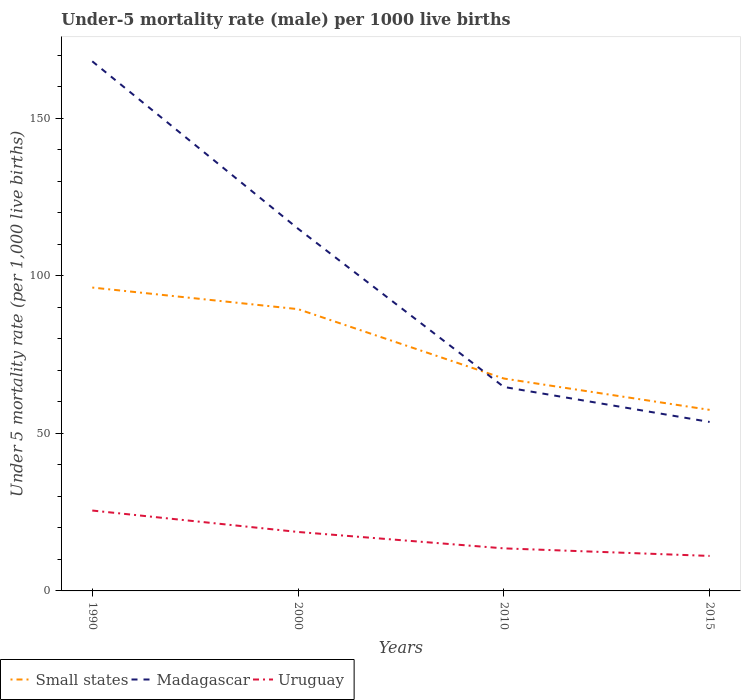How many different coloured lines are there?
Your response must be concise. 3. Does the line corresponding to Uruguay intersect with the line corresponding to Madagascar?
Your answer should be compact. No. Across all years, what is the maximum under-five mortality rate in Small states?
Provide a succinct answer. 57.43. In which year was the under-five mortality rate in Madagascar maximum?
Give a very brief answer. 2015. What is the total under-five mortality rate in Uruguay in the graph?
Keep it short and to the point. 6.8. What is the difference between the highest and the second highest under-five mortality rate in Small states?
Make the answer very short. 38.8. What is the difference between the highest and the lowest under-five mortality rate in Small states?
Make the answer very short. 2. Are the values on the major ticks of Y-axis written in scientific E-notation?
Your response must be concise. No. Does the graph contain grids?
Your answer should be compact. No. Where does the legend appear in the graph?
Your answer should be very brief. Bottom left. What is the title of the graph?
Your answer should be compact. Under-5 mortality rate (male) per 1000 live births. Does "Kuwait" appear as one of the legend labels in the graph?
Make the answer very short. No. What is the label or title of the Y-axis?
Give a very brief answer. Under 5 mortality rate (per 1,0 live births). What is the Under 5 mortality rate (per 1,000 live births) in Small states in 1990?
Your response must be concise. 96.23. What is the Under 5 mortality rate (per 1,000 live births) in Madagascar in 1990?
Your answer should be compact. 168. What is the Under 5 mortality rate (per 1,000 live births) of Uruguay in 1990?
Ensure brevity in your answer.  25.5. What is the Under 5 mortality rate (per 1,000 live births) in Small states in 2000?
Your answer should be very brief. 89.38. What is the Under 5 mortality rate (per 1,000 live births) of Madagascar in 2000?
Keep it short and to the point. 114.9. What is the Under 5 mortality rate (per 1,000 live births) of Uruguay in 2000?
Your answer should be very brief. 18.7. What is the Under 5 mortality rate (per 1,000 live births) of Small states in 2010?
Give a very brief answer. 67.37. What is the Under 5 mortality rate (per 1,000 live births) of Madagascar in 2010?
Your response must be concise. 64.7. What is the Under 5 mortality rate (per 1,000 live births) of Small states in 2015?
Give a very brief answer. 57.43. What is the Under 5 mortality rate (per 1,000 live births) of Madagascar in 2015?
Offer a very short reply. 53.6. Across all years, what is the maximum Under 5 mortality rate (per 1,000 live births) in Small states?
Offer a very short reply. 96.23. Across all years, what is the maximum Under 5 mortality rate (per 1,000 live births) of Madagascar?
Give a very brief answer. 168. Across all years, what is the minimum Under 5 mortality rate (per 1,000 live births) of Small states?
Give a very brief answer. 57.43. Across all years, what is the minimum Under 5 mortality rate (per 1,000 live births) in Madagascar?
Provide a short and direct response. 53.6. Across all years, what is the minimum Under 5 mortality rate (per 1,000 live births) of Uruguay?
Provide a succinct answer. 11.1. What is the total Under 5 mortality rate (per 1,000 live births) of Small states in the graph?
Offer a terse response. 310.42. What is the total Under 5 mortality rate (per 1,000 live births) in Madagascar in the graph?
Your answer should be compact. 401.2. What is the total Under 5 mortality rate (per 1,000 live births) of Uruguay in the graph?
Make the answer very short. 68.8. What is the difference between the Under 5 mortality rate (per 1,000 live births) of Small states in 1990 and that in 2000?
Your response must be concise. 6.85. What is the difference between the Under 5 mortality rate (per 1,000 live births) of Madagascar in 1990 and that in 2000?
Keep it short and to the point. 53.1. What is the difference between the Under 5 mortality rate (per 1,000 live births) in Small states in 1990 and that in 2010?
Provide a succinct answer. 28.86. What is the difference between the Under 5 mortality rate (per 1,000 live births) of Madagascar in 1990 and that in 2010?
Offer a very short reply. 103.3. What is the difference between the Under 5 mortality rate (per 1,000 live births) of Uruguay in 1990 and that in 2010?
Your answer should be very brief. 12. What is the difference between the Under 5 mortality rate (per 1,000 live births) in Small states in 1990 and that in 2015?
Offer a very short reply. 38.8. What is the difference between the Under 5 mortality rate (per 1,000 live births) in Madagascar in 1990 and that in 2015?
Your answer should be compact. 114.4. What is the difference between the Under 5 mortality rate (per 1,000 live births) in Uruguay in 1990 and that in 2015?
Give a very brief answer. 14.4. What is the difference between the Under 5 mortality rate (per 1,000 live births) in Small states in 2000 and that in 2010?
Provide a short and direct response. 22.01. What is the difference between the Under 5 mortality rate (per 1,000 live births) of Madagascar in 2000 and that in 2010?
Make the answer very short. 50.2. What is the difference between the Under 5 mortality rate (per 1,000 live births) in Small states in 2000 and that in 2015?
Offer a terse response. 31.95. What is the difference between the Under 5 mortality rate (per 1,000 live births) of Madagascar in 2000 and that in 2015?
Make the answer very short. 61.3. What is the difference between the Under 5 mortality rate (per 1,000 live births) of Uruguay in 2000 and that in 2015?
Your answer should be compact. 7.6. What is the difference between the Under 5 mortality rate (per 1,000 live births) in Small states in 2010 and that in 2015?
Offer a very short reply. 9.94. What is the difference between the Under 5 mortality rate (per 1,000 live births) of Uruguay in 2010 and that in 2015?
Provide a short and direct response. 2.4. What is the difference between the Under 5 mortality rate (per 1,000 live births) in Small states in 1990 and the Under 5 mortality rate (per 1,000 live births) in Madagascar in 2000?
Ensure brevity in your answer.  -18.67. What is the difference between the Under 5 mortality rate (per 1,000 live births) of Small states in 1990 and the Under 5 mortality rate (per 1,000 live births) of Uruguay in 2000?
Your answer should be compact. 77.53. What is the difference between the Under 5 mortality rate (per 1,000 live births) in Madagascar in 1990 and the Under 5 mortality rate (per 1,000 live births) in Uruguay in 2000?
Your answer should be compact. 149.3. What is the difference between the Under 5 mortality rate (per 1,000 live births) of Small states in 1990 and the Under 5 mortality rate (per 1,000 live births) of Madagascar in 2010?
Offer a terse response. 31.53. What is the difference between the Under 5 mortality rate (per 1,000 live births) in Small states in 1990 and the Under 5 mortality rate (per 1,000 live births) in Uruguay in 2010?
Keep it short and to the point. 82.73. What is the difference between the Under 5 mortality rate (per 1,000 live births) of Madagascar in 1990 and the Under 5 mortality rate (per 1,000 live births) of Uruguay in 2010?
Your answer should be compact. 154.5. What is the difference between the Under 5 mortality rate (per 1,000 live births) in Small states in 1990 and the Under 5 mortality rate (per 1,000 live births) in Madagascar in 2015?
Ensure brevity in your answer.  42.63. What is the difference between the Under 5 mortality rate (per 1,000 live births) in Small states in 1990 and the Under 5 mortality rate (per 1,000 live births) in Uruguay in 2015?
Give a very brief answer. 85.13. What is the difference between the Under 5 mortality rate (per 1,000 live births) of Madagascar in 1990 and the Under 5 mortality rate (per 1,000 live births) of Uruguay in 2015?
Your answer should be compact. 156.9. What is the difference between the Under 5 mortality rate (per 1,000 live births) in Small states in 2000 and the Under 5 mortality rate (per 1,000 live births) in Madagascar in 2010?
Keep it short and to the point. 24.68. What is the difference between the Under 5 mortality rate (per 1,000 live births) in Small states in 2000 and the Under 5 mortality rate (per 1,000 live births) in Uruguay in 2010?
Your answer should be compact. 75.88. What is the difference between the Under 5 mortality rate (per 1,000 live births) in Madagascar in 2000 and the Under 5 mortality rate (per 1,000 live births) in Uruguay in 2010?
Give a very brief answer. 101.4. What is the difference between the Under 5 mortality rate (per 1,000 live births) in Small states in 2000 and the Under 5 mortality rate (per 1,000 live births) in Madagascar in 2015?
Keep it short and to the point. 35.78. What is the difference between the Under 5 mortality rate (per 1,000 live births) of Small states in 2000 and the Under 5 mortality rate (per 1,000 live births) of Uruguay in 2015?
Provide a short and direct response. 78.28. What is the difference between the Under 5 mortality rate (per 1,000 live births) of Madagascar in 2000 and the Under 5 mortality rate (per 1,000 live births) of Uruguay in 2015?
Your response must be concise. 103.8. What is the difference between the Under 5 mortality rate (per 1,000 live births) in Small states in 2010 and the Under 5 mortality rate (per 1,000 live births) in Madagascar in 2015?
Make the answer very short. 13.77. What is the difference between the Under 5 mortality rate (per 1,000 live births) of Small states in 2010 and the Under 5 mortality rate (per 1,000 live births) of Uruguay in 2015?
Provide a succinct answer. 56.27. What is the difference between the Under 5 mortality rate (per 1,000 live births) in Madagascar in 2010 and the Under 5 mortality rate (per 1,000 live births) in Uruguay in 2015?
Provide a succinct answer. 53.6. What is the average Under 5 mortality rate (per 1,000 live births) in Small states per year?
Make the answer very short. 77.6. What is the average Under 5 mortality rate (per 1,000 live births) of Madagascar per year?
Make the answer very short. 100.3. What is the average Under 5 mortality rate (per 1,000 live births) in Uruguay per year?
Your answer should be compact. 17.2. In the year 1990, what is the difference between the Under 5 mortality rate (per 1,000 live births) of Small states and Under 5 mortality rate (per 1,000 live births) of Madagascar?
Your answer should be compact. -71.77. In the year 1990, what is the difference between the Under 5 mortality rate (per 1,000 live births) in Small states and Under 5 mortality rate (per 1,000 live births) in Uruguay?
Keep it short and to the point. 70.73. In the year 1990, what is the difference between the Under 5 mortality rate (per 1,000 live births) of Madagascar and Under 5 mortality rate (per 1,000 live births) of Uruguay?
Offer a very short reply. 142.5. In the year 2000, what is the difference between the Under 5 mortality rate (per 1,000 live births) of Small states and Under 5 mortality rate (per 1,000 live births) of Madagascar?
Provide a short and direct response. -25.52. In the year 2000, what is the difference between the Under 5 mortality rate (per 1,000 live births) of Small states and Under 5 mortality rate (per 1,000 live births) of Uruguay?
Give a very brief answer. 70.68. In the year 2000, what is the difference between the Under 5 mortality rate (per 1,000 live births) in Madagascar and Under 5 mortality rate (per 1,000 live births) in Uruguay?
Ensure brevity in your answer.  96.2. In the year 2010, what is the difference between the Under 5 mortality rate (per 1,000 live births) of Small states and Under 5 mortality rate (per 1,000 live births) of Madagascar?
Provide a succinct answer. 2.67. In the year 2010, what is the difference between the Under 5 mortality rate (per 1,000 live births) of Small states and Under 5 mortality rate (per 1,000 live births) of Uruguay?
Your answer should be compact. 53.87. In the year 2010, what is the difference between the Under 5 mortality rate (per 1,000 live births) in Madagascar and Under 5 mortality rate (per 1,000 live births) in Uruguay?
Your response must be concise. 51.2. In the year 2015, what is the difference between the Under 5 mortality rate (per 1,000 live births) in Small states and Under 5 mortality rate (per 1,000 live births) in Madagascar?
Ensure brevity in your answer.  3.83. In the year 2015, what is the difference between the Under 5 mortality rate (per 1,000 live births) in Small states and Under 5 mortality rate (per 1,000 live births) in Uruguay?
Your answer should be compact. 46.33. In the year 2015, what is the difference between the Under 5 mortality rate (per 1,000 live births) of Madagascar and Under 5 mortality rate (per 1,000 live births) of Uruguay?
Ensure brevity in your answer.  42.5. What is the ratio of the Under 5 mortality rate (per 1,000 live births) in Small states in 1990 to that in 2000?
Offer a terse response. 1.08. What is the ratio of the Under 5 mortality rate (per 1,000 live births) of Madagascar in 1990 to that in 2000?
Offer a very short reply. 1.46. What is the ratio of the Under 5 mortality rate (per 1,000 live births) in Uruguay in 1990 to that in 2000?
Offer a terse response. 1.36. What is the ratio of the Under 5 mortality rate (per 1,000 live births) in Small states in 1990 to that in 2010?
Ensure brevity in your answer.  1.43. What is the ratio of the Under 5 mortality rate (per 1,000 live births) in Madagascar in 1990 to that in 2010?
Keep it short and to the point. 2.6. What is the ratio of the Under 5 mortality rate (per 1,000 live births) in Uruguay in 1990 to that in 2010?
Your answer should be compact. 1.89. What is the ratio of the Under 5 mortality rate (per 1,000 live births) of Small states in 1990 to that in 2015?
Ensure brevity in your answer.  1.68. What is the ratio of the Under 5 mortality rate (per 1,000 live births) in Madagascar in 1990 to that in 2015?
Keep it short and to the point. 3.13. What is the ratio of the Under 5 mortality rate (per 1,000 live births) in Uruguay in 1990 to that in 2015?
Your response must be concise. 2.3. What is the ratio of the Under 5 mortality rate (per 1,000 live births) in Small states in 2000 to that in 2010?
Your answer should be compact. 1.33. What is the ratio of the Under 5 mortality rate (per 1,000 live births) in Madagascar in 2000 to that in 2010?
Keep it short and to the point. 1.78. What is the ratio of the Under 5 mortality rate (per 1,000 live births) in Uruguay in 2000 to that in 2010?
Give a very brief answer. 1.39. What is the ratio of the Under 5 mortality rate (per 1,000 live births) in Small states in 2000 to that in 2015?
Your response must be concise. 1.56. What is the ratio of the Under 5 mortality rate (per 1,000 live births) of Madagascar in 2000 to that in 2015?
Your response must be concise. 2.14. What is the ratio of the Under 5 mortality rate (per 1,000 live births) in Uruguay in 2000 to that in 2015?
Give a very brief answer. 1.68. What is the ratio of the Under 5 mortality rate (per 1,000 live births) in Small states in 2010 to that in 2015?
Ensure brevity in your answer.  1.17. What is the ratio of the Under 5 mortality rate (per 1,000 live births) of Madagascar in 2010 to that in 2015?
Offer a very short reply. 1.21. What is the ratio of the Under 5 mortality rate (per 1,000 live births) in Uruguay in 2010 to that in 2015?
Provide a short and direct response. 1.22. What is the difference between the highest and the second highest Under 5 mortality rate (per 1,000 live births) in Small states?
Give a very brief answer. 6.85. What is the difference between the highest and the second highest Under 5 mortality rate (per 1,000 live births) of Madagascar?
Your answer should be compact. 53.1. What is the difference between the highest and the lowest Under 5 mortality rate (per 1,000 live births) in Small states?
Your answer should be compact. 38.8. What is the difference between the highest and the lowest Under 5 mortality rate (per 1,000 live births) in Madagascar?
Keep it short and to the point. 114.4. 